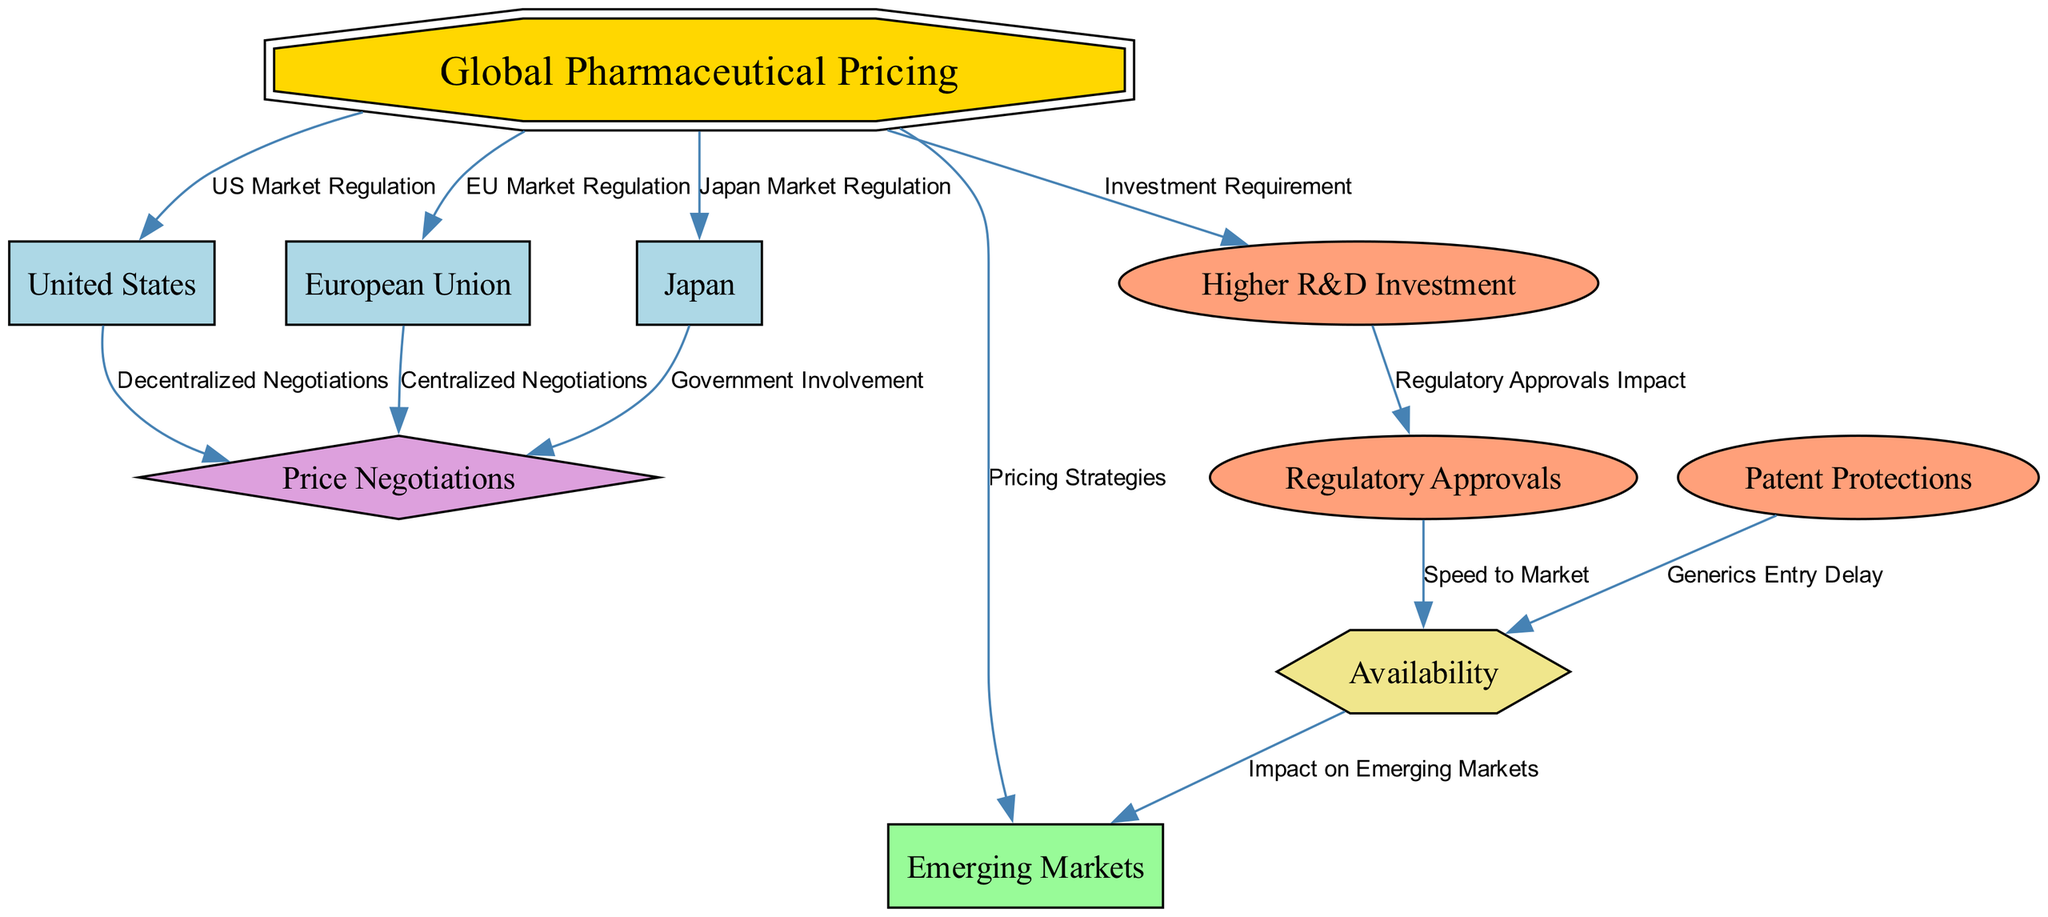How many countries are represented in the diagram? The diagram includes three specific countries: the United States, the European Union, and Japan. These are clearly labeled in the nodes as "United States", "European Union", and "Japan". Therefore, the total count is three.
Answer: 3 What does "N4" represent in the diagram? Referring to the node id "N4", it has the label "Japan", which indicates that it represents the country Japan in the context of global pharmaceutical pricing regulations.
Answer: Japan What type of relationship exists between “European Union” and “Price Negotiations”? The node labeled “European Union” (N3) has an outgoing edge labeled "Centralized Negotiations" pointing to the “Price Negotiations” node (N9). This indicates that the EU conducts centralized negotiations as part of its market regulation.
Answer: Centralized Negotiations What is the primary outcome affected by "Regulatory Approvals"? The node "Regulatory Approvals" (N7) points to "Availability" (N10) with an edge labeled "Speed to Market". This connection indicates that regulatory approvals directly impact the speed at which drugs become available in the market.
Answer: Availability Which node in the diagram is associated with higher research and development investment? The node labeled "Higher R&D Investment" (N6) is directly linked to the main node "Global Pharmaceutical Pricing" (N1), indicating that it is a factor associated with pharmaceutical pricing on a global scale.
Answer: Higher R&D Investment How many edges originate from the United States node? The United States node (N2) has two outgoing edges. One leads to “Price Negotiations” labeled "Decentralized Negotiations", and another leads to “Higher R&D Investment” labeled "Investment Requirement". Therefore, the total number of edges is two.
Answer: 2 What is the consequence of "Patent Protections"? The "Patent Protections" node (N8) points to the "Availability" node (N10) with the label "Generics Entry Delay", indicating that patent protections lead to delays in the entry of generics, affecting the overall availability of drugs in the market.
Answer: Generics Entry Delay What is the relationship between "Higher R&D Investment" and "Regulatory Approvals"? There is an edge from "Higher R&D Investment" (N6) to "Regulatory Approvals" (N7) labeled "Regulatory Approvals Impact". This shows that there is a direct impact that higher investments in research and development have on regulatory approvals, suggesting that it may lead to more favorable or quicker approvals.
Answer: Regulatory Approvals Impact How does availability affect "Emerging Markets"? The "Availability" node (N10) has a direct edge pointing to the "Emerging Markets" node (N5) labeled "Impact on Emerging Markets". This means that the availability of drugs has a significant influence on the access to pharmaceuticals in emerging market regions.
Answer: Impact on Emerging Markets 